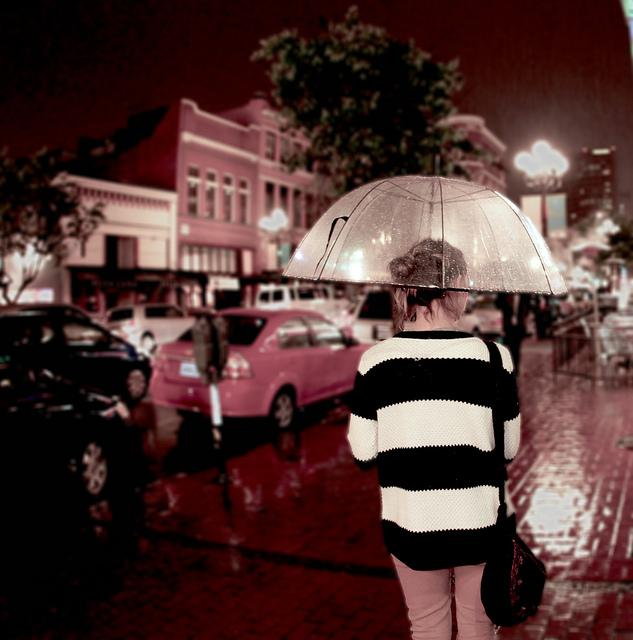Why is the woman using an umbrella?

Choices:
A) prevent heat
B) prevent sunburn
C) snow
D) rain rain 